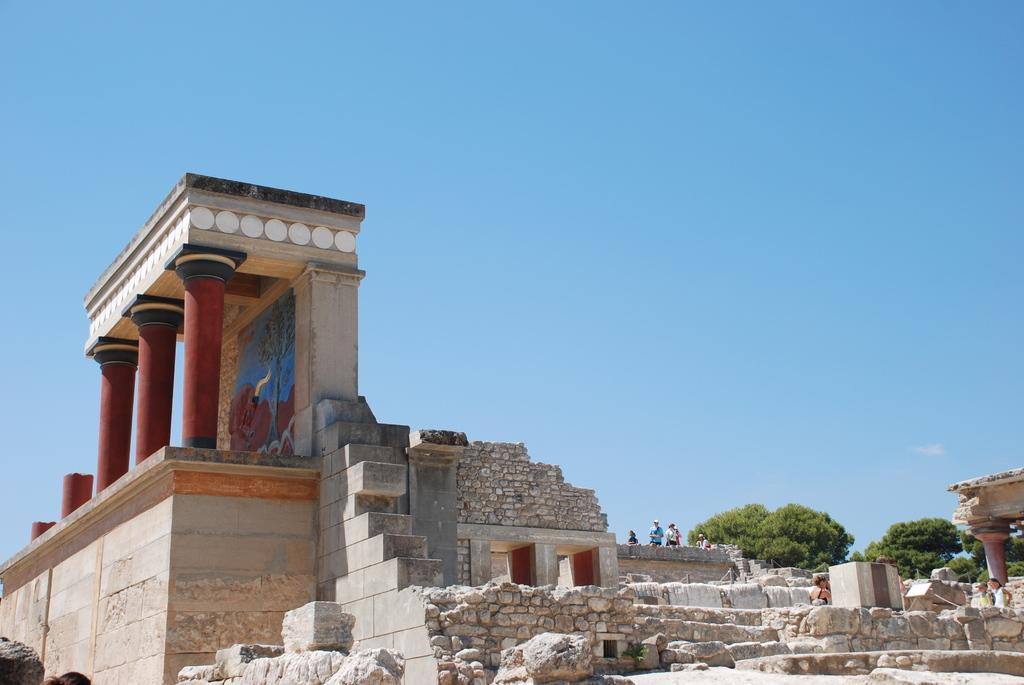Who or what can be seen in the image? There are people in the image. What type of structures are present in the image? There is ancient architecture and pillars in the image. What natural elements can be seen in the image? There are rocks and trees in the image. What can be seen in the background of the image? The sky is visible in the background of the image. What advice is the person in the image giving to the rocks? There is no indication in the image that the people are giving advice to the rocks, as rocks do not have the ability to receive or understand advice. 